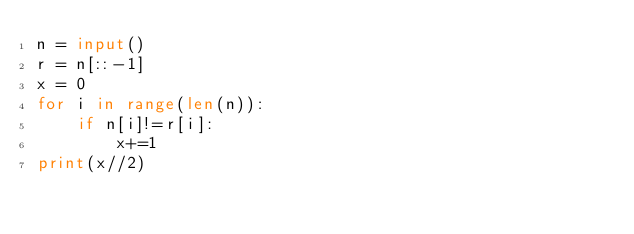<code> <loc_0><loc_0><loc_500><loc_500><_Python_>n = input()
r = n[::-1]
x = 0
for i in range(len(n)):
    if n[i]!=r[i]:
        x+=1
print(x//2)</code> 